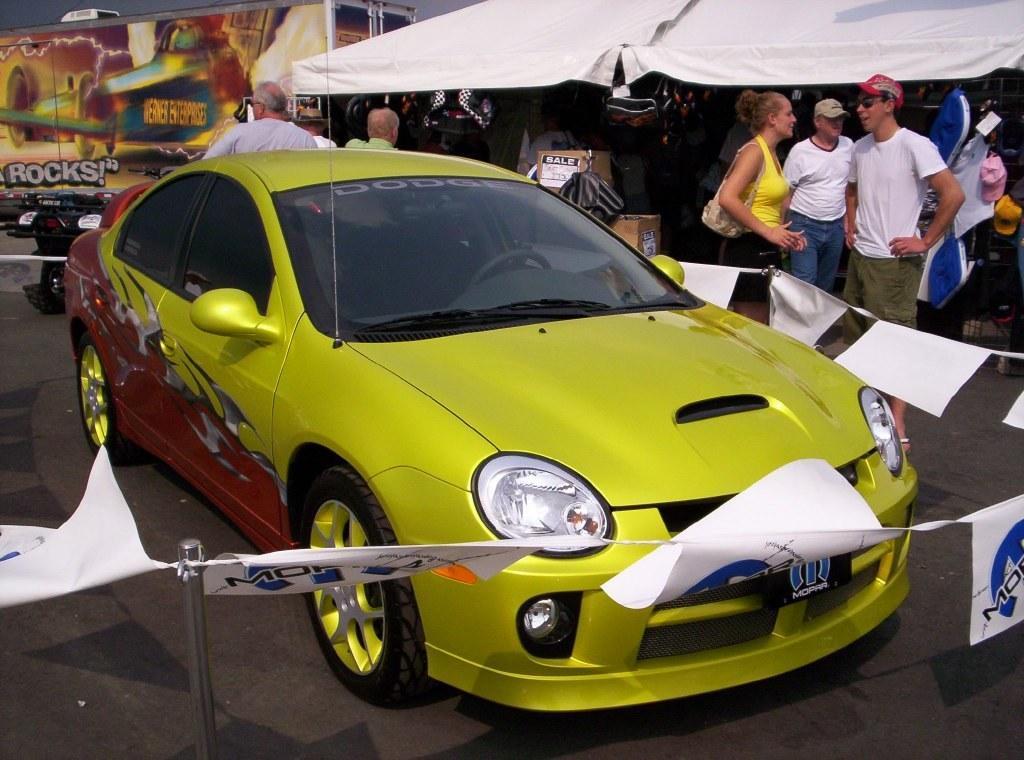Could you give a brief overview of what you see in this image? In this image I see a car over here and there are few papers around it. In the background I see few people , boxes and the tent. 